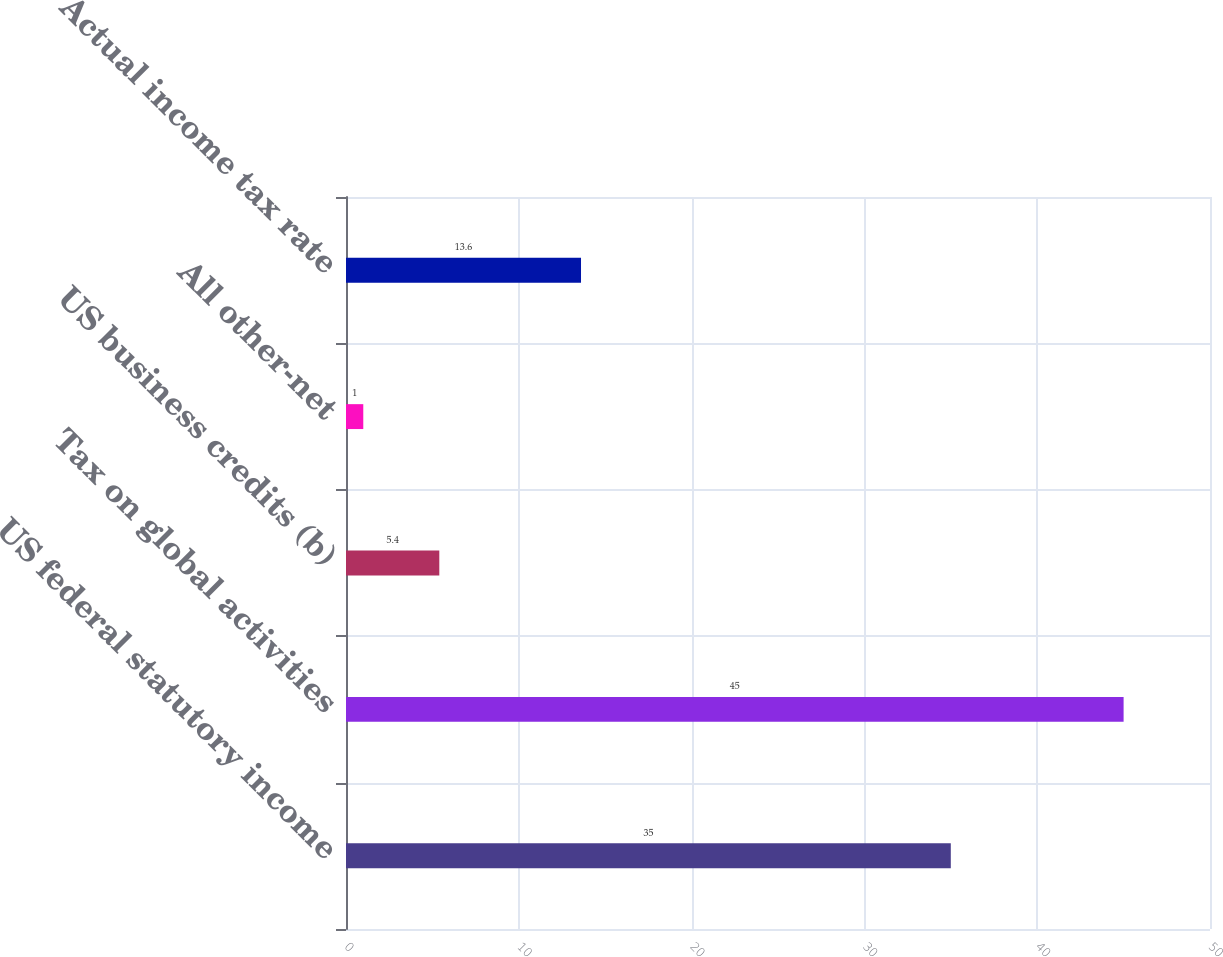Convert chart to OTSL. <chart><loc_0><loc_0><loc_500><loc_500><bar_chart><fcel>US federal statutory income<fcel>Tax on global activities<fcel>US business credits (b)<fcel>All other-net<fcel>Actual income tax rate<nl><fcel>35<fcel>45<fcel>5.4<fcel>1<fcel>13.6<nl></chart> 